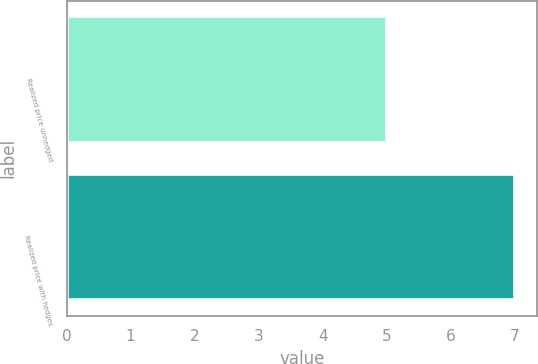Convert chart to OTSL. <chart><loc_0><loc_0><loc_500><loc_500><bar_chart><fcel>Realized price unhedged<fcel>Realized price with hedges<nl><fcel>5<fcel>7<nl></chart> 